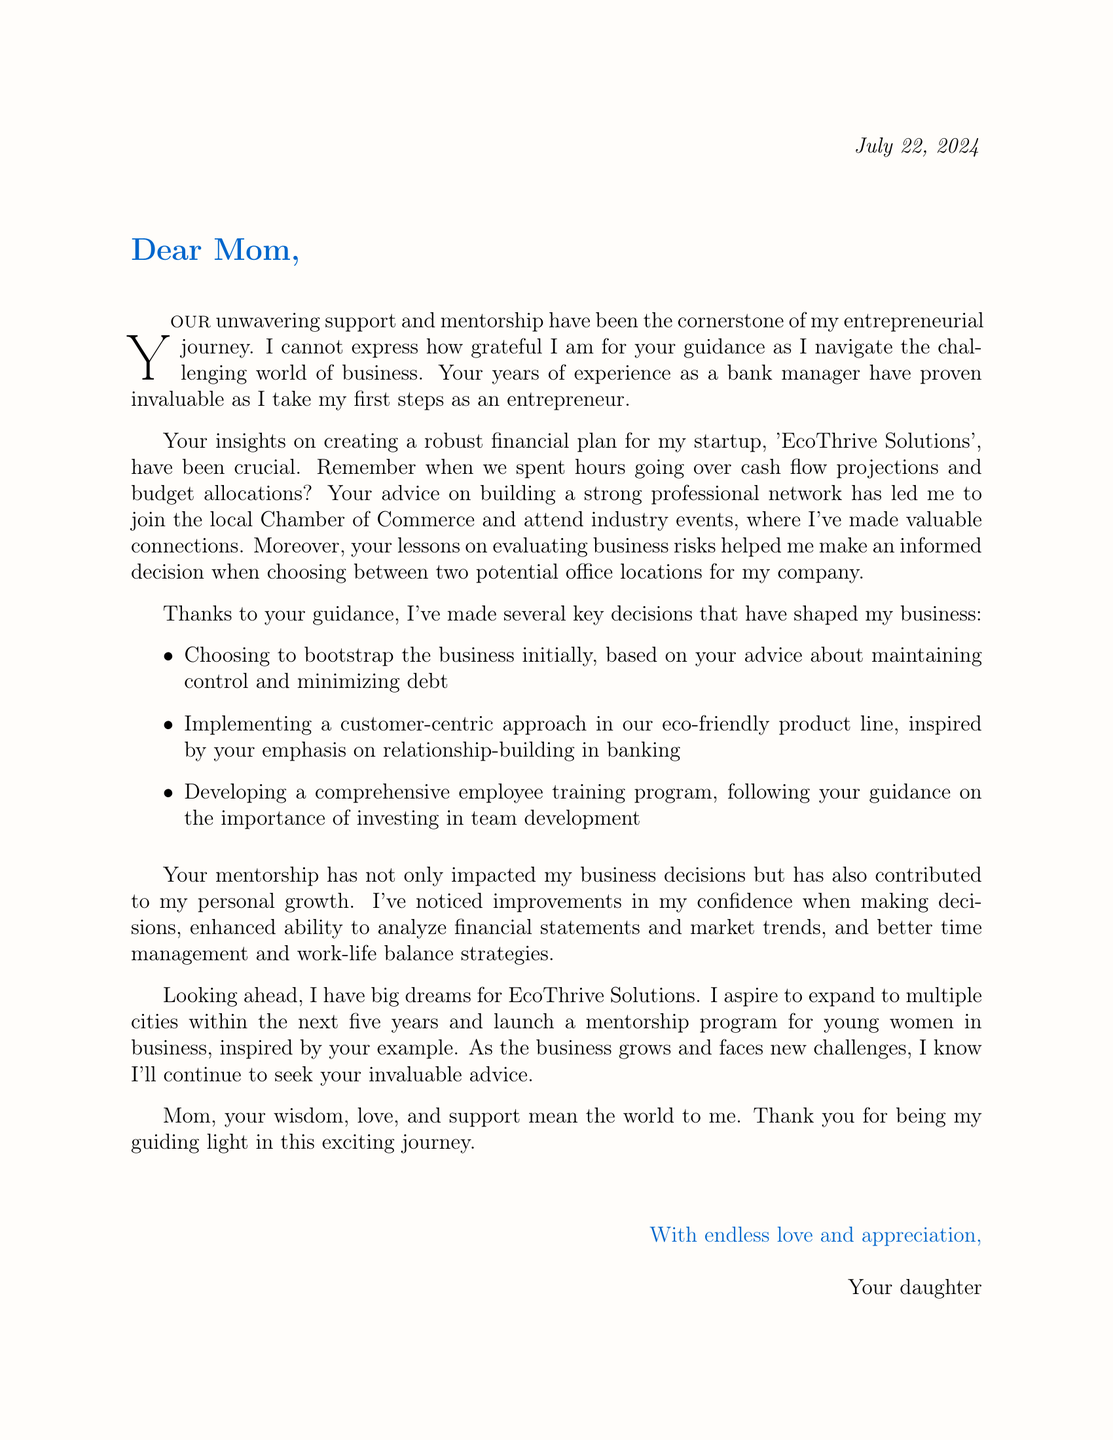What is the name of the startup? The letter mentions the startup as 'EcoThrive Solutions'.
Answer: EcoThrive Solutions Who is the letter addressed to? The opening line indicates that the letter is addressed to "Mom".
Answer: Mom What is one area of advice provided by the mother? The document lists several areas of advice, one of which is financial planning.
Answer: Financial planning Which professional organization did the author join? The letter refers to joining the "local Chamber of Commerce" as part of networking efforts.
Answer: local Chamber of Commerce What is a key decision made regarding business funding? The author mentions choosing to bootstrap the business initially, based on her mother's advice.
Answer: bootstrap the business How many years does the author aspire to expand her business? The future aspiration mentioned states expanding to multiple cities within the "next five years".
Answer: five years What does the author want to launch for young women? The document expresses the author’s desire to launch a "mentorship program for young women in business".
Answer: mentorship program What has improved due to the mother's mentorship? The author indicates that her "confidence in decision-making" has improved as a result of her mother's guidance.
Answer: confidence in decision-making What closing phrase does the author use? The letter concludes with "With endless love and appreciation," before the signature.
Answer: With endless love and appreciation 